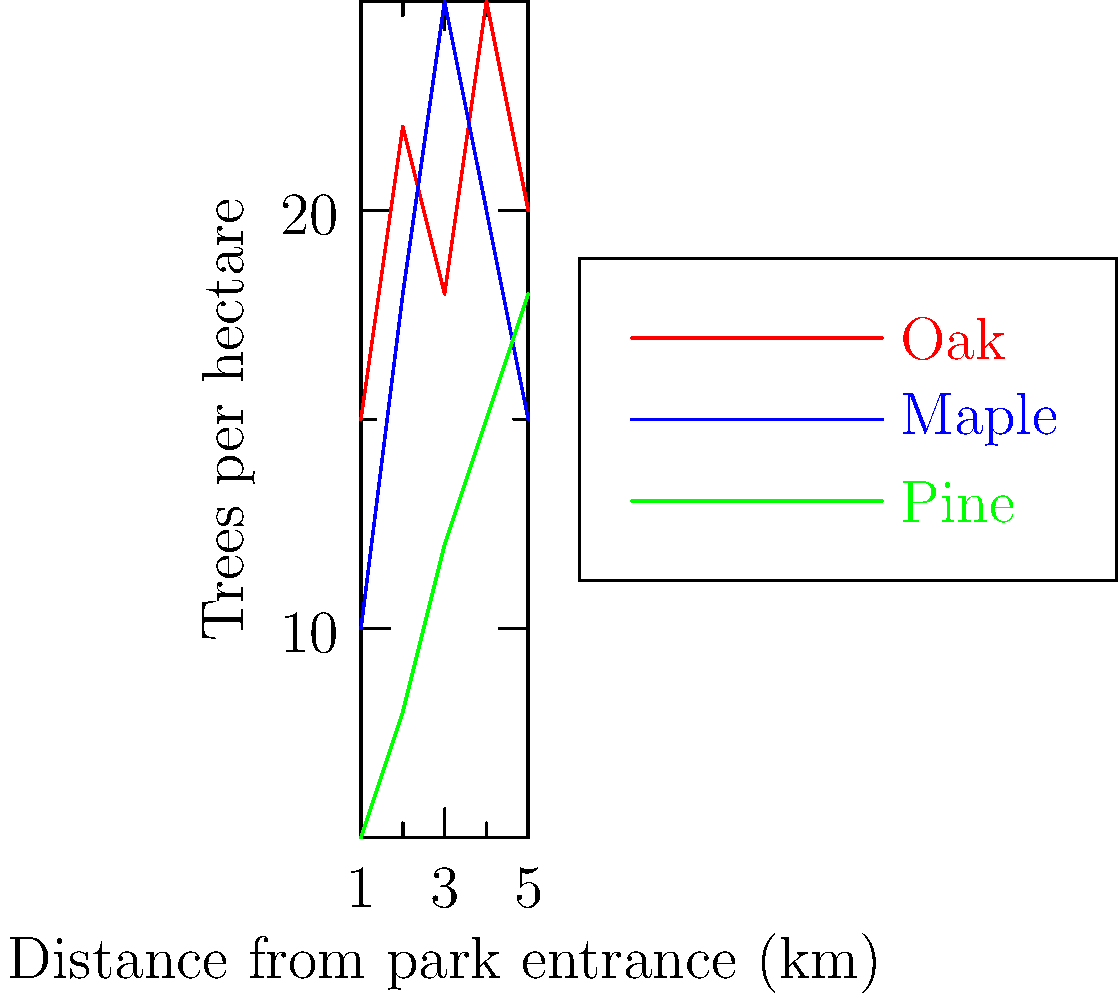Based on the graph showing tree density distribution in the park, which tree species shows the highest overall density across the 5 km distance from the park entrance, and how might this information influence the setting of your historical fiction novel? To determine the tree species with the highest overall density, we need to analyze the graph data:

1. Oak (red line):
   Sum of densities = 15 + 22 + 18 + 25 + 20 = 100 trees/hectare

2. Maple (blue line):
   Sum of densities = 10 + 18 + 25 + 20 + 15 = 88 trees/hectare

3. Pine (green line):
   Sum of densities = 5 + 8 + 12 + 15 + 18 = 58 trees/hectare

Oak has the highest total density across the 5 km distance.

For a historical fiction novel, this information could influence the setting by:
1. Describing the predominant oak canopy and its seasonal changes.
2. Using oak-related activities (e.g., acorn gathering) in the plot.
3. Incorporating the gradual increase in pine density as characters move deeper into the park.
4. Reflecting on how the tree distribution might have affected historical land use or settlement patterns.
Answer: Oak; shapes forest ambiance and potential plot elements 